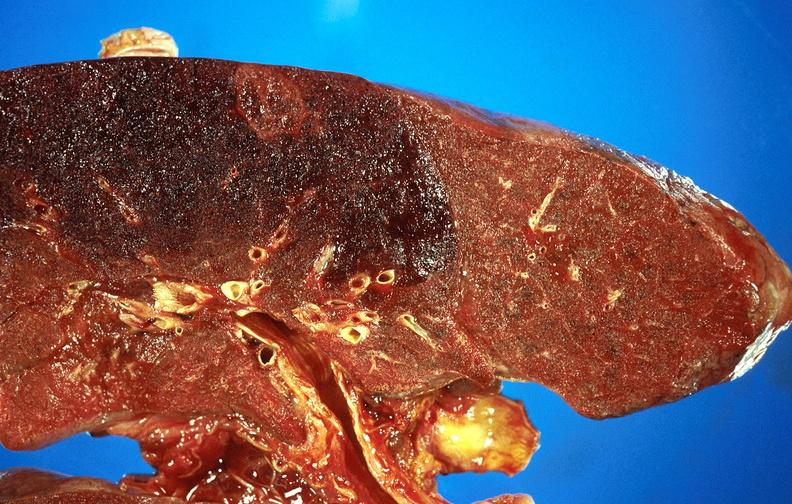where is this?
Answer the question using a single word or phrase. Lung 